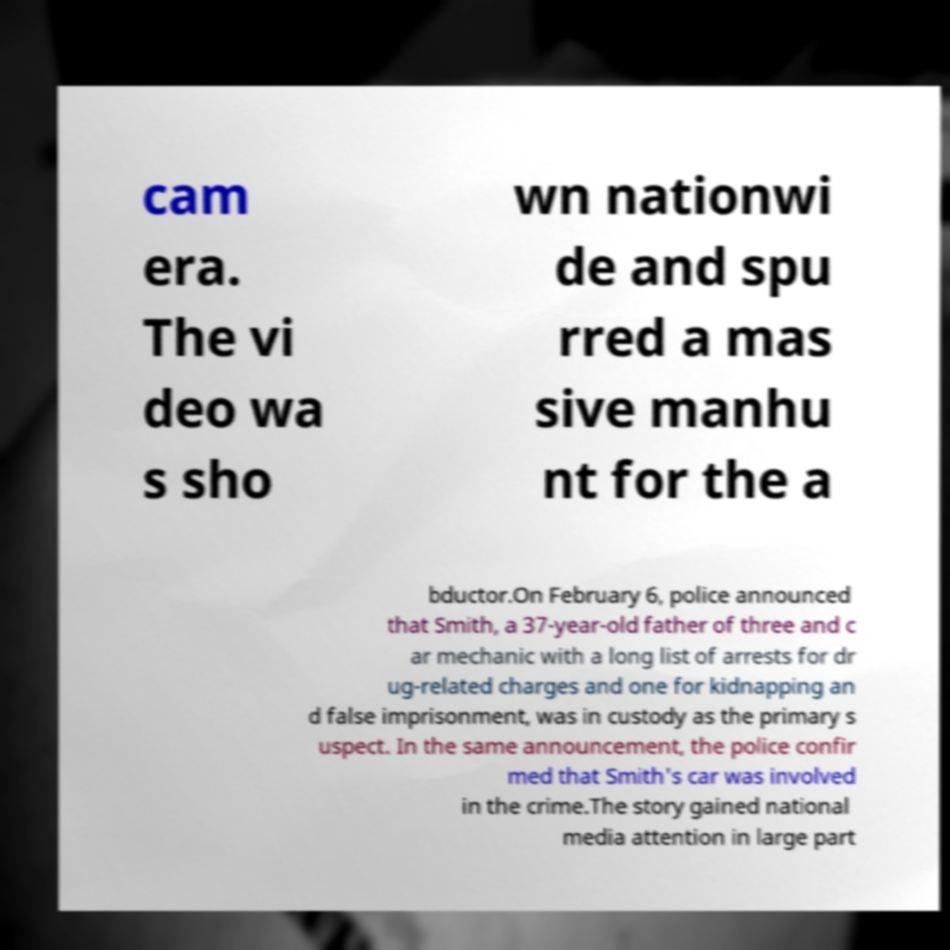Please identify and transcribe the text found in this image. cam era. The vi deo wa s sho wn nationwi de and spu rred a mas sive manhu nt for the a bductor.On February 6, police announced that Smith, a 37-year-old father of three and c ar mechanic with a long list of arrests for dr ug-related charges and one for kidnapping an d false imprisonment, was in custody as the primary s uspect. In the same announcement, the police confir med that Smith's car was involved in the crime.The story gained national media attention in large part 